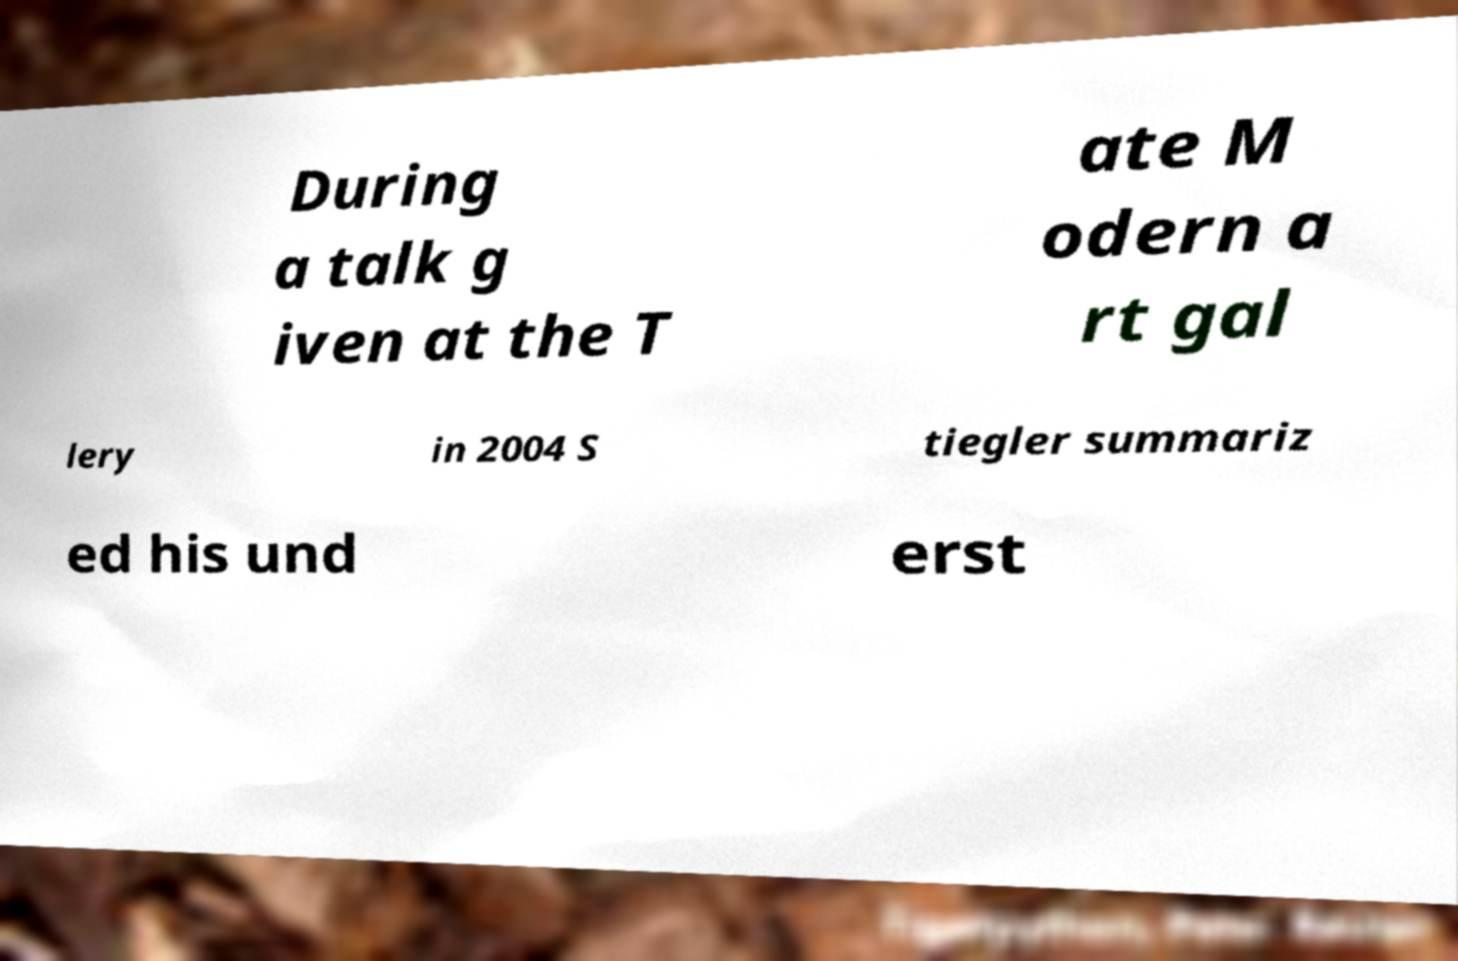What messages or text are displayed in this image? I need them in a readable, typed format. During a talk g iven at the T ate M odern a rt gal lery in 2004 S tiegler summariz ed his und erst 